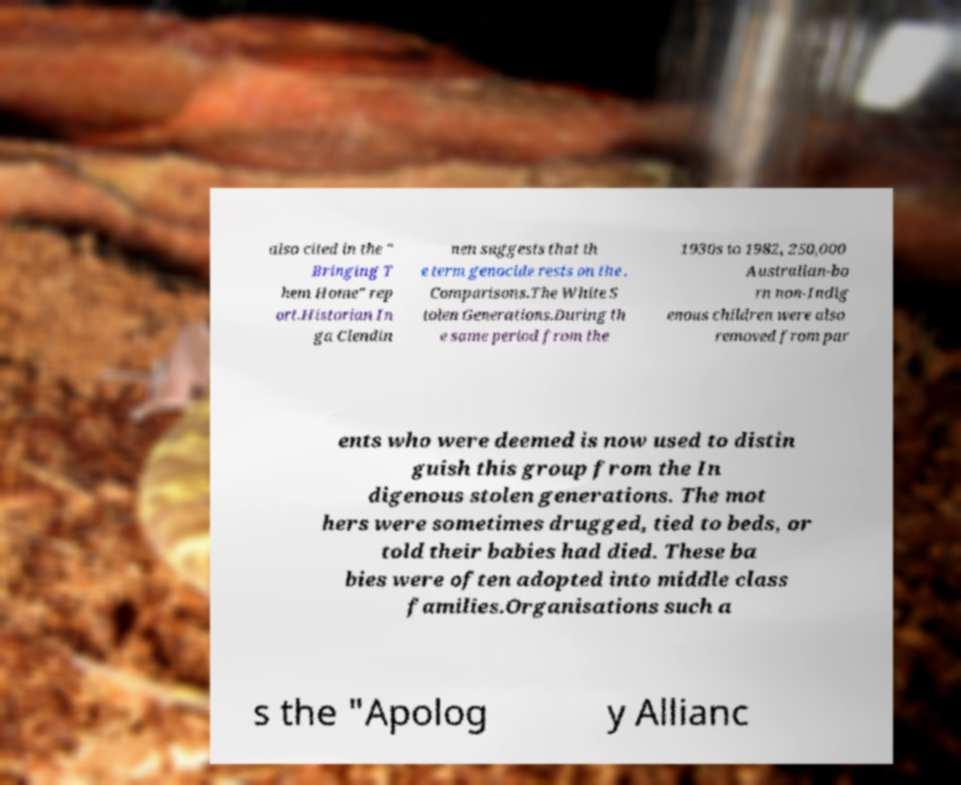For documentation purposes, I need the text within this image transcribed. Could you provide that? also cited in the " Bringing T hem Home" rep ort.Historian In ga Clendin nen suggests that th e term genocide rests on the . Comparisons.The White S tolen Generations.During th e same period from the 1930s to 1982, 250,000 Australian-bo rn non-Indig enous children were also removed from par ents who were deemed is now used to distin guish this group from the In digenous stolen generations. The mot hers were sometimes drugged, tied to beds, or told their babies had died. These ba bies were often adopted into middle class families.Organisations such a s the "Apolog y Allianc 